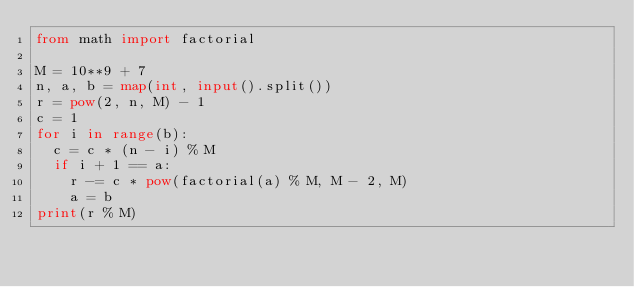<code> <loc_0><loc_0><loc_500><loc_500><_Python_>from math import factorial
 
M = 10**9 + 7
n, a, b = map(int, input().split())
r = pow(2, n, M) - 1
c = 1
for i in range(b):
  c = c * (n - i) % M
  if i + 1 == a:
    r -= c * pow(factorial(a) % M, M - 2, M)
    a = b
print(r % M)
</code> 